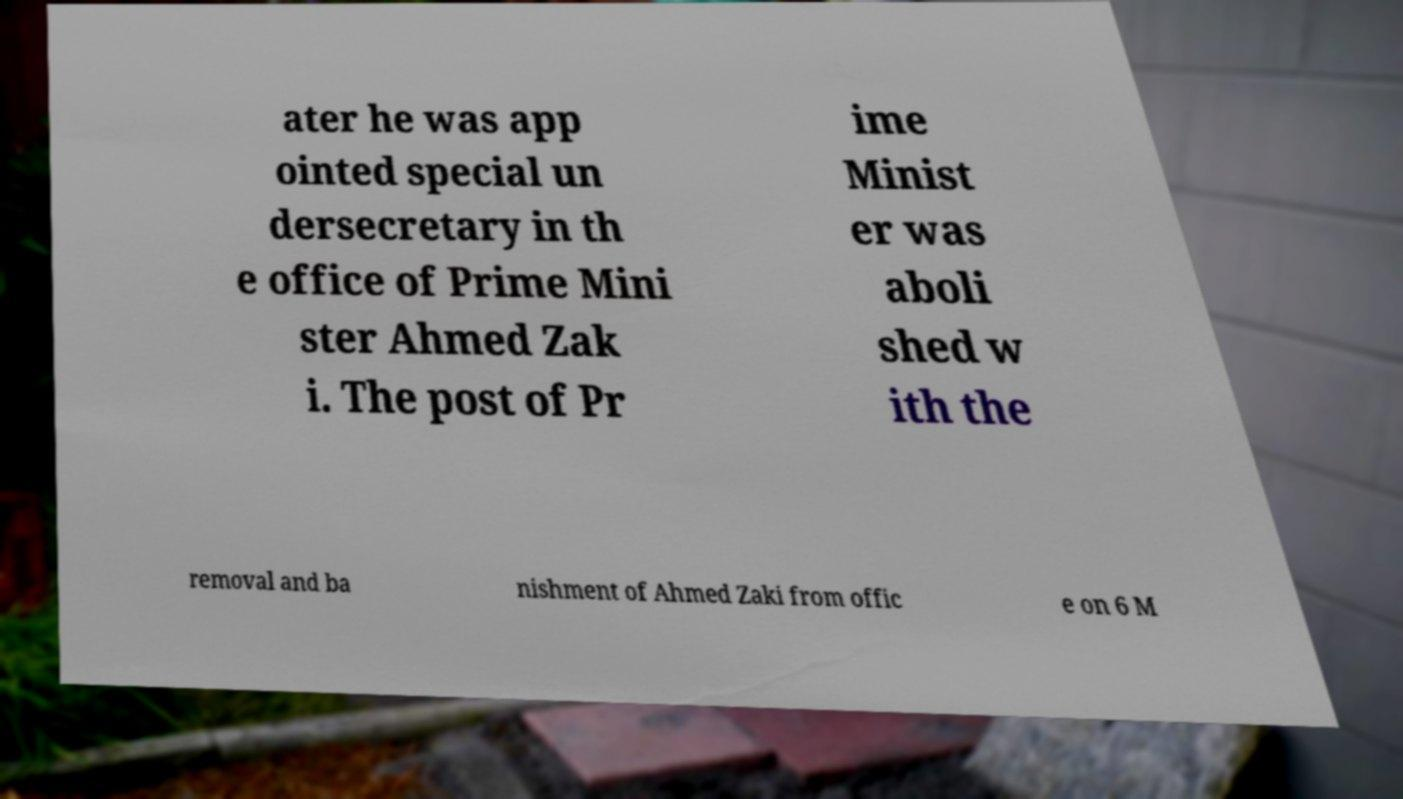Could you assist in decoding the text presented in this image and type it out clearly? ater he was app ointed special un dersecretary in th e office of Prime Mini ster Ahmed Zak i. The post of Pr ime Minist er was aboli shed w ith the removal and ba nishment of Ahmed Zaki from offic e on 6 M 